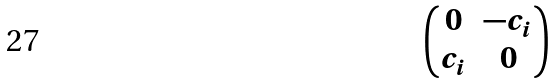Convert formula to latex. <formula><loc_0><loc_0><loc_500><loc_500>\begin{pmatrix} 0 & - c _ { i } \\ c _ { i } & 0 \end{pmatrix}</formula> 